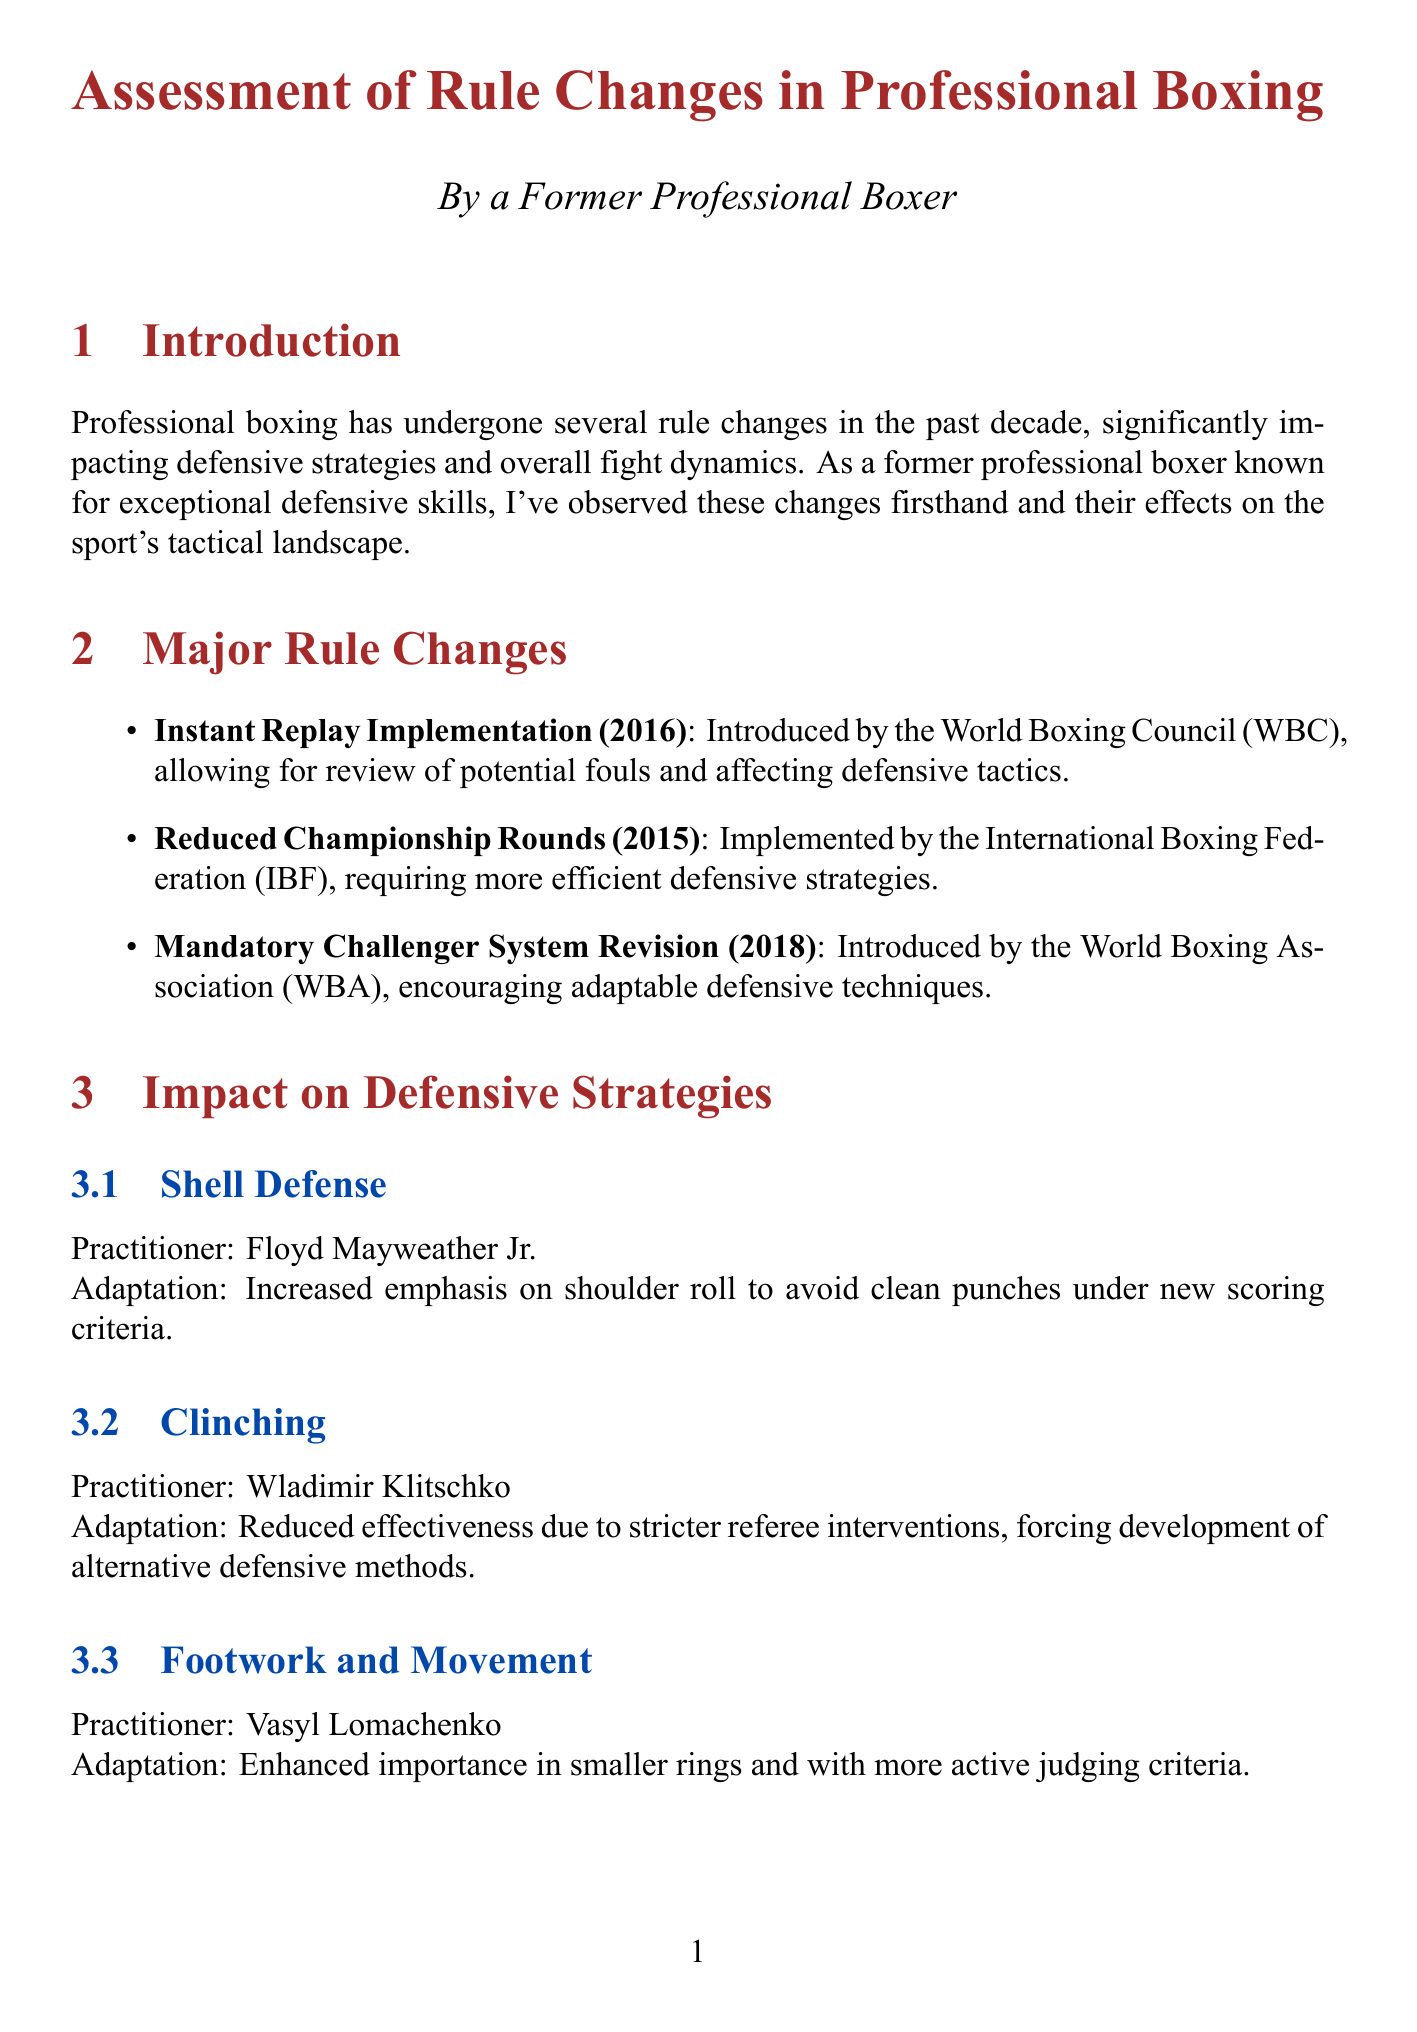What year was the Instant Replay Implementation introduced? The Instant Replay Implementation was introduced in 2016 by the World Boxing Council (WBC).
Answer: 2016 Who is known for the Shell Defense strategy? The Shell Defense strategy is associated with Floyd Mayweather Jr. as noted in the document.
Answer: Floyd Mayweather Jr What major rule change was made in 2015? In 2015, the Reduced Championship Rounds rule was implemented by the International Boxing Federation (IBF).
Answer: Reduced Championship Rounds Which fighter improved head movement in response to stricter judging? Canelo Alvarez made defensive adjustments in head movement to adapt to stricter judging in the fight against Gennady Golovkin II.
Answer: Canelo Alvarez What technology has increased focus on punch accuracy and defensive efficiency? Punch stat systems have increased the focus on punch accuracy and defensive efficiency in professional boxing.
Answer: Punch stat systems How has clinching as a defensive strategy changed? The effectiveness of clinching has reduced due to stricter referee interventions, requiring alternative methods.
Answer: Reduced effectiveness Who provided the opinion that pure defensive fighters are almost extinct? Teddy Atlas, a boxing trainer and analyst, expressed that pure defensive fighters are almost extinct due to the new rules.
Answer: Teddy Atlas What is a necessary adaptation for fighters mentioned in the conclusion? According to the conclusion of the report, adaptation is key to success in the modern boxing landscape.
Answer: Adaptation 